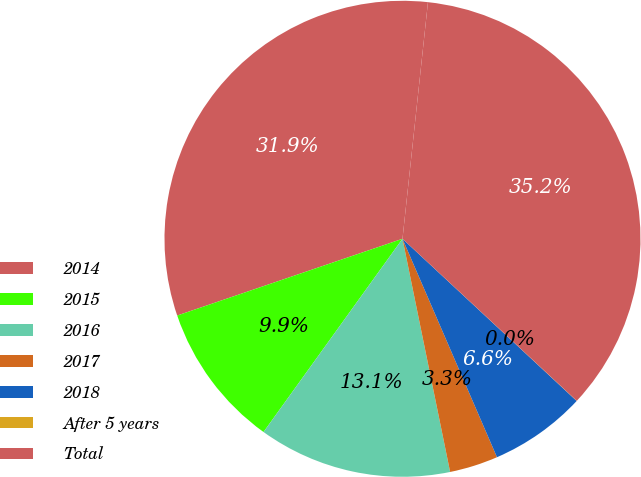Convert chart. <chart><loc_0><loc_0><loc_500><loc_500><pie_chart><fcel>2014<fcel>2015<fcel>2016<fcel>2017<fcel>2018<fcel>After 5 years<fcel>Total<nl><fcel>31.93%<fcel>9.85%<fcel>13.13%<fcel>3.29%<fcel>6.57%<fcel>0.01%<fcel>35.21%<nl></chart> 